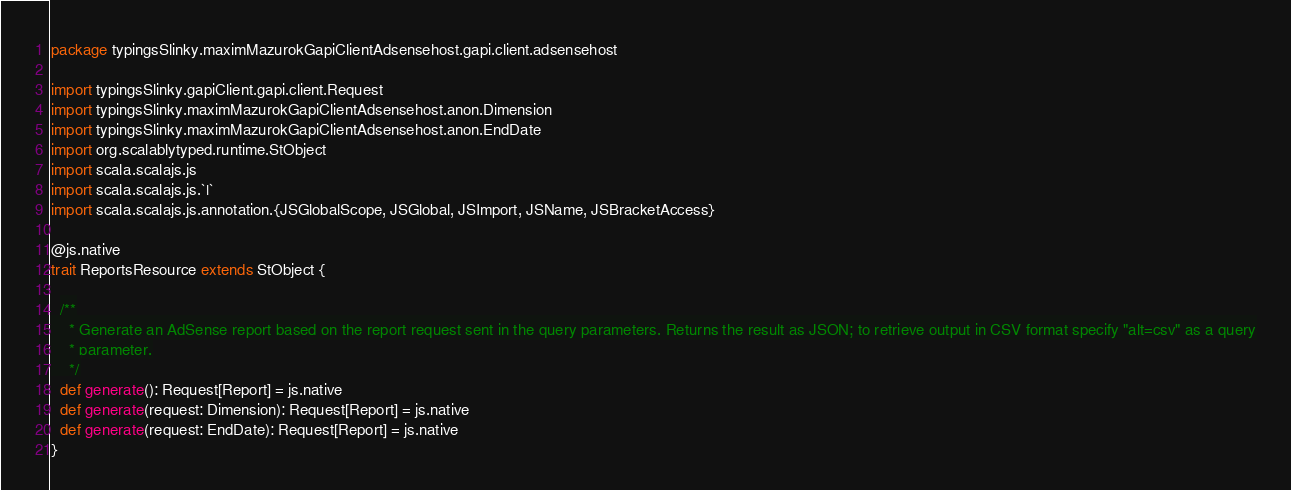Convert code to text. <code><loc_0><loc_0><loc_500><loc_500><_Scala_>package typingsSlinky.maximMazurokGapiClientAdsensehost.gapi.client.adsensehost

import typingsSlinky.gapiClient.gapi.client.Request
import typingsSlinky.maximMazurokGapiClientAdsensehost.anon.Dimension
import typingsSlinky.maximMazurokGapiClientAdsensehost.anon.EndDate
import org.scalablytyped.runtime.StObject
import scala.scalajs.js
import scala.scalajs.js.`|`
import scala.scalajs.js.annotation.{JSGlobalScope, JSGlobal, JSImport, JSName, JSBracketAccess}

@js.native
trait ReportsResource extends StObject {
  
  /**
    * Generate an AdSense report based on the report request sent in the query parameters. Returns the result as JSON; to retrieve output in CSV format specify "alt=csv" as a query
    * parameter.
    */
  def generate(): Request[Report] = js.native
  def generate(request: Dimension): Request[Report] = js.native
  def generate(request: EndDate): Request[Report] = js.native
}
</code> 